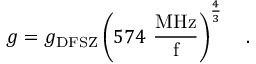<formula> <loc_0><loc_0><loc_500><loc_500>g = g _ { D F S Z } \left ( { 5 7 4 \frac { M H z } { f } } \right ) ^ { \frac { 4 } { 3 } } \ .</formula> 